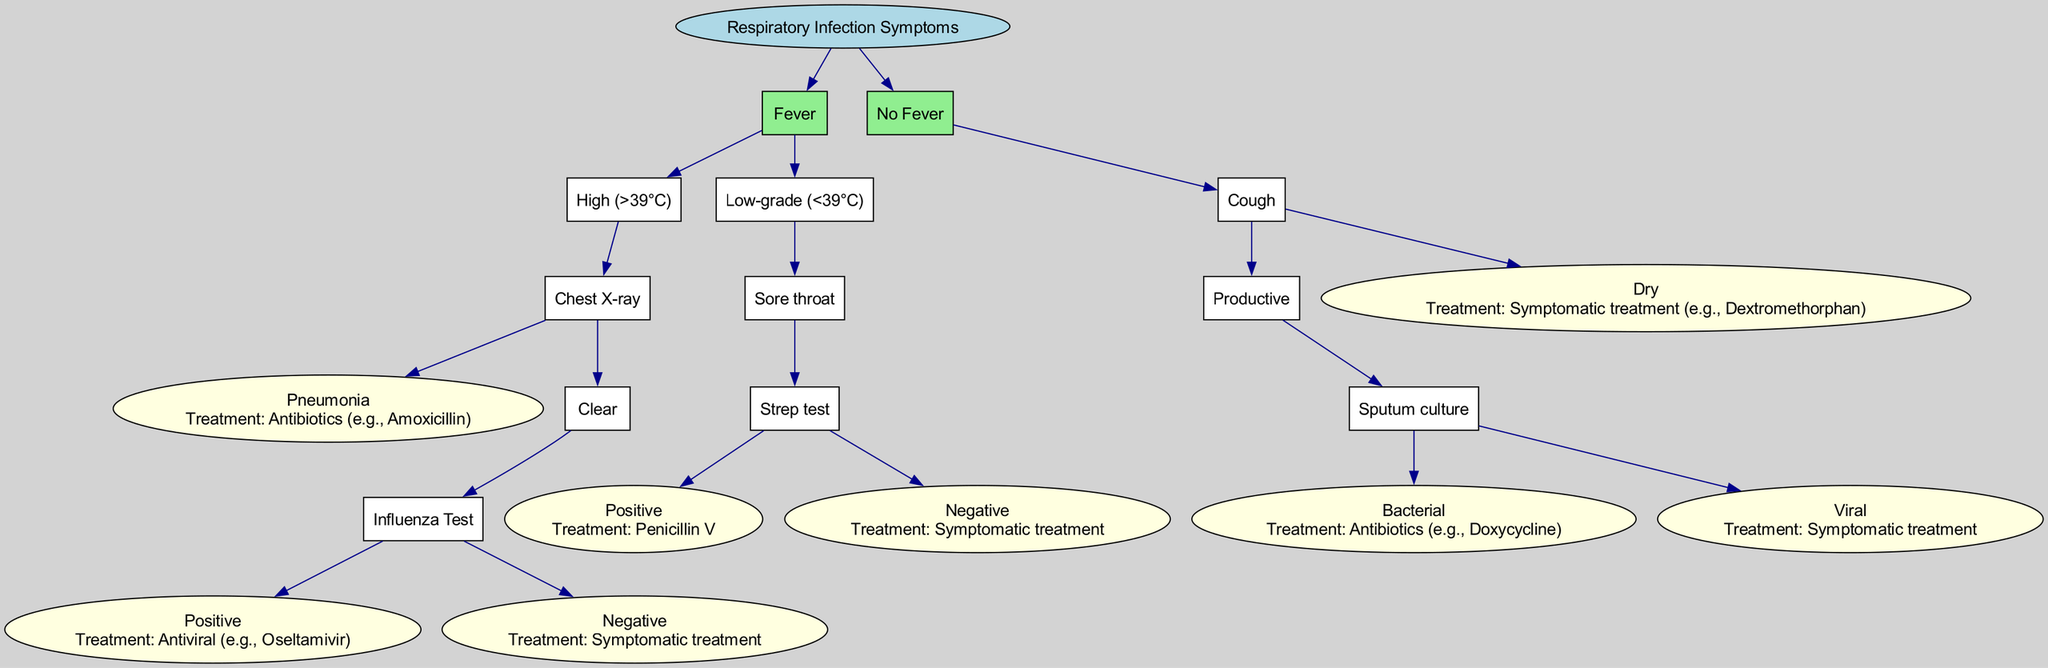What is the root of the diagram? The root of the diagram is labeled as "Respiratory Infection Symptoms", which signifies the primary focus of the decision tree.
Answer: Respiratory Infection Symptoms How many main branches are there? The diagram has two main branches: "Fever" and "No Fever". This indicates two primary pathways based on the presence of fever.
Answer: 2 What treatment is prescribed for a positive Strep test? According to the diagram, if the Strep test is positive, the treatment prescribed is "Penicillin V". This is a direct result of flowing through the decision tree to that specific node.
Answer: Penicillin V What do you do if the influenza test result is negative? The diagram indicates that if the influenza test is negative, the recommended course of action is "Symptomatic treatment". This is found in the pathway after the influenza test evaluation.
Answer: Symptomatic treatment What happens after a positive sputum culture? If the sputum culture indicates a bacterial cause, the treatment recommended is "Antibiotics (e.g., Doxycycline)". This is derived from navigating through the "Cough" branch and looking at the "Sputum culture" node.
Answer: Antibiotics (e.g., Doxycycline) If a patient has a dry cough without fever, what is the treatment? The diagram specifies that if a patient has a dry cough, the treatment is "Symptomatic treatment (e.g., Dextromethorphan)". This outcome is reached directly from the corresponding node for a dry cough.
Answer: Symptomatic treatment (e.g., Dextromethorphan) Which condition leads to the recommendation of antibiotics based on the fever category? The condition that leads to the recommendation of antibiotics comes from the "High (>39°C)" fever category leading to a "Pneumonia" diagnosis, thus warranting antibiotic treatment. This illustrates how the flow from fever to test to diagnosis can affect treatment decisions.
Answer: Pneumonia What is the treatment if a patient has a productive cough with a viral cause identified from a sputum culture? If the sputum culture shows a viral origin for a productive cough, the treatment is "Symptomatic treatment". This result is reached by evaluating the branches regarding cough type and sputum culture results.
Answer: Symptomatic treatment 